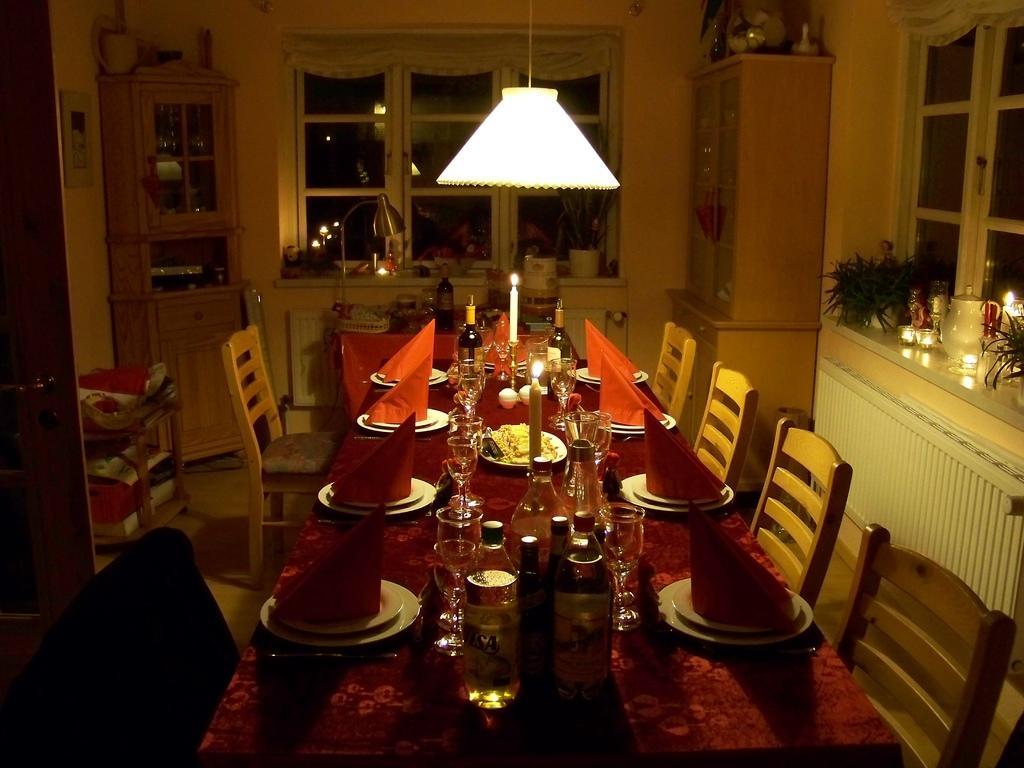How would you summarize this image in a sentence or two? In this picture we can see a table with plates, bottles, candles, glasses, clothes on it and beside this table we can see chairs and in the background we can see lamps, windows, cupboards, lights, jug, door, frame on the wall and some objects. 